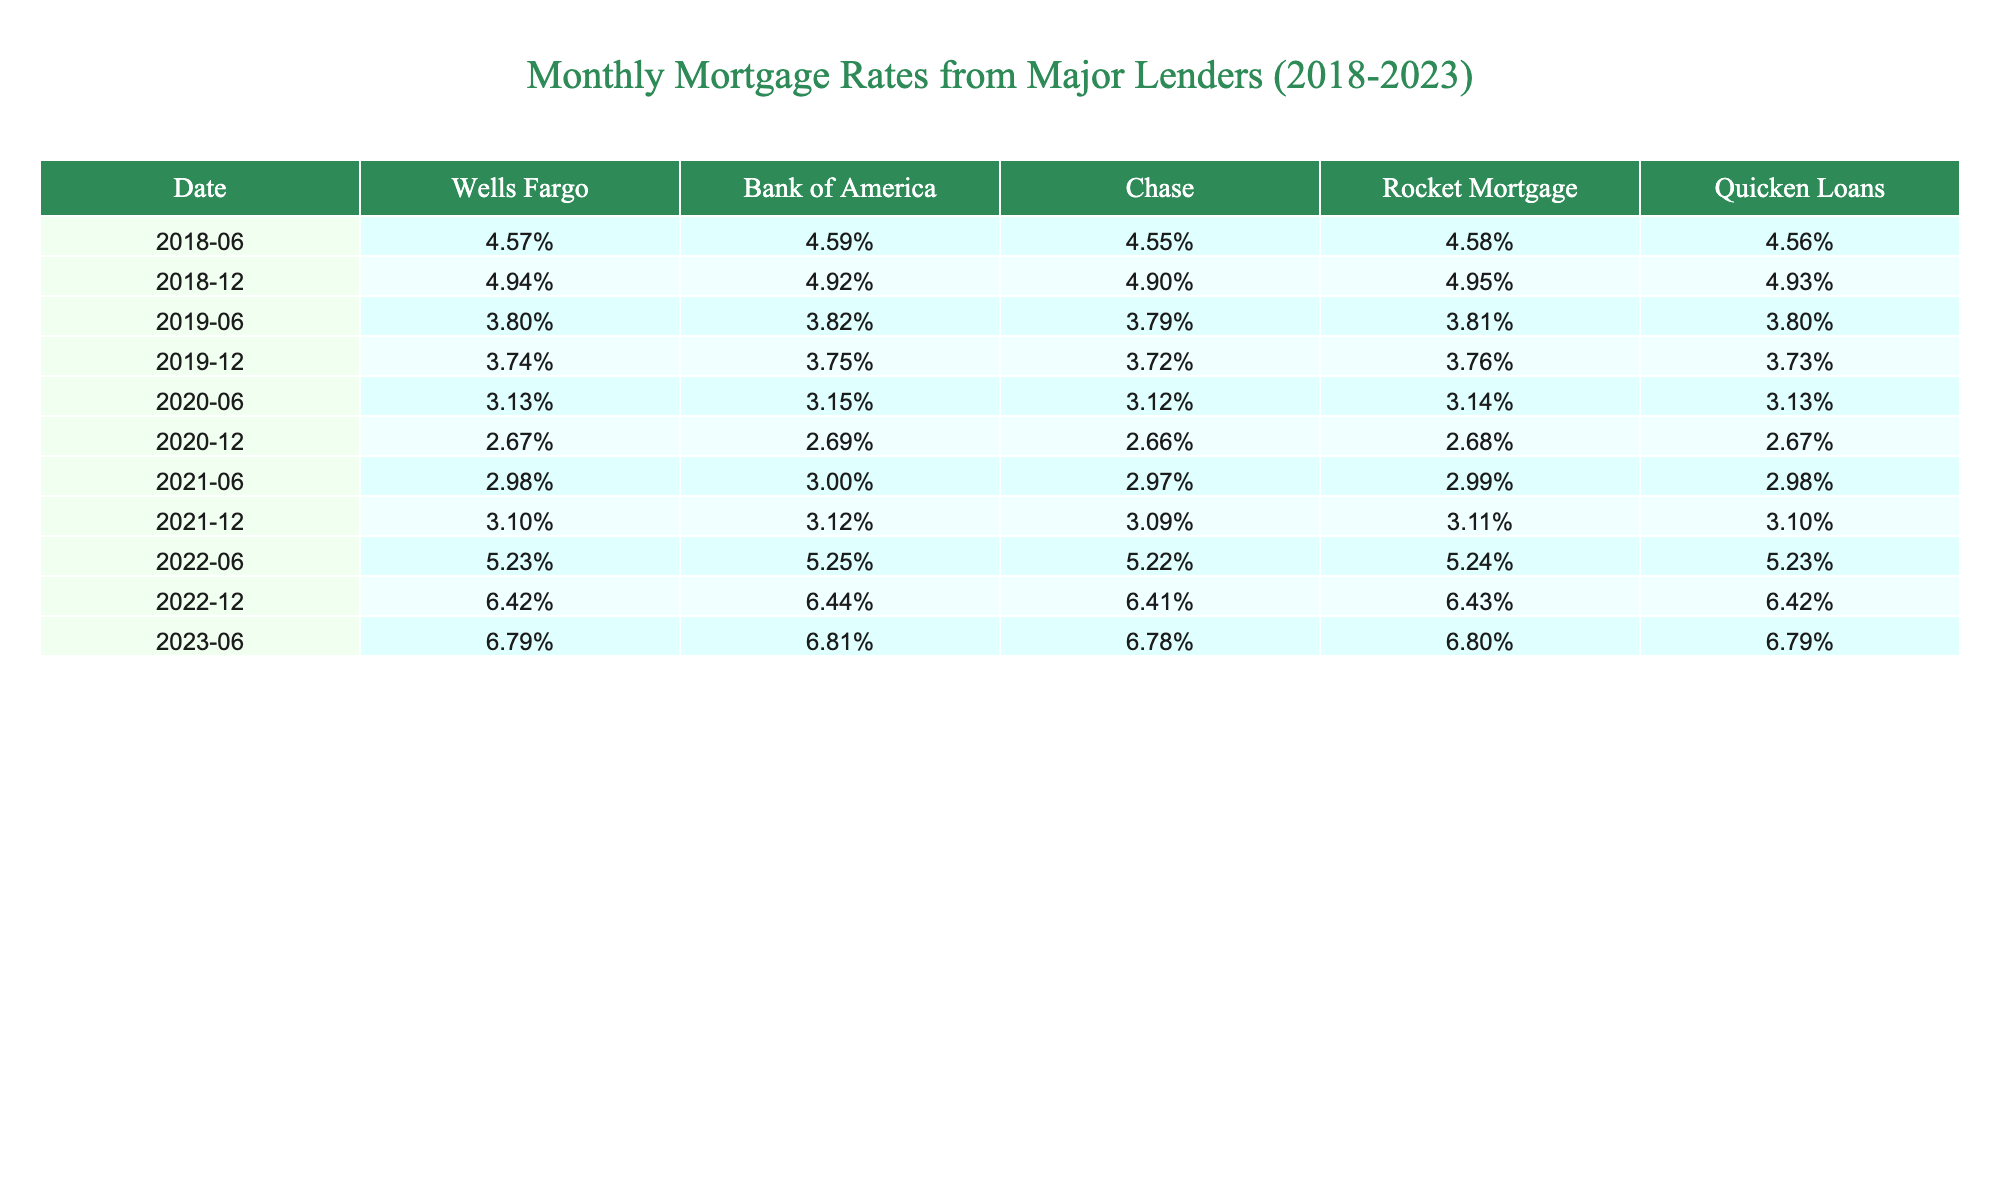What was the mortgage rate from Wells Fargo in June 2019? The table lists the mortgage rates by date. In June 2019, the rate for Wells Fargo is 3.80%.
Answer: 3.80% What is the highest mortgage rate recorded in the table? Scanning the table, the highest mortgage rate is 6.79%, recorded in June 2023.
Answer: 6.79% Which lender offered the lowest mortgage rates in 2020? Looking at the rates for 2020, the lowest rate is found in December from Quicken Loans at 2.67%.
Answer: Quicken Loans at 2.67% What was the average mortgage rate from Chase in 2022? First, locate the rates for Chase in 2022: June (5.22%), December (6.41%). The average is (5.22% + 6.41%) / 2 = 5.815%.
Answer: 5.815% Was there a mortgage rate increase from the end of 2020 to the end of 2021 for Quicken Loans? The table shows the rates: Quicken Loans in December 2020 (2.67%) and in December 2021 (3.10%). Since 3.10% is greater than 2.67%, this indicates an increase.
Answer: Yes What was the change in the mortgage rate from Bank of America between June 2022 and June 2023? The rate from Bank of America in June 2022 is 5.25% and in June 2023 is 6.81%. The change is 6.81% - 5.25% = 1.56%.
Answer: 1.56% Which lender had the most consistent rates over the five years? Reviewing the rates, Quicken Loans and Rocket Mortgage both show rates with less fluctuation compared to others. Quicken Loans rates did not vary widely compared to the others.
Answer: Quicken Loans What is the percentage increase in average mortgage rates from 2020 to 2022 for Wells Fargo? Calculate the average rate for Wells Fargo in 2020 (2.90%) and in 2022 (6.82%). The increase is (6.82% - 2.90%) / 2.90% * 100 = 134.55%.
Answer: 134.55% Did Chase's mortgage rates increase from 2018 to 2023? In 2018, Chase's rate was 4.55% and in 2023 it reached 6.78%. This indicates an increase over the years.
Answer: Yes What were the average mortgage rates for all lenders in June 2021? First, identify the rates for June 2021: Wells Fargo (2.98%), Bank of America (3.00%), Chase (2.97%), Rocket Mortgage (2.99%), Quicken Loans (2.98%). The average is (2.98% + 3.00% + 2.97% + 2.99% + 2.98%) / 5 = 2.984%.
Answer: 2.984% 